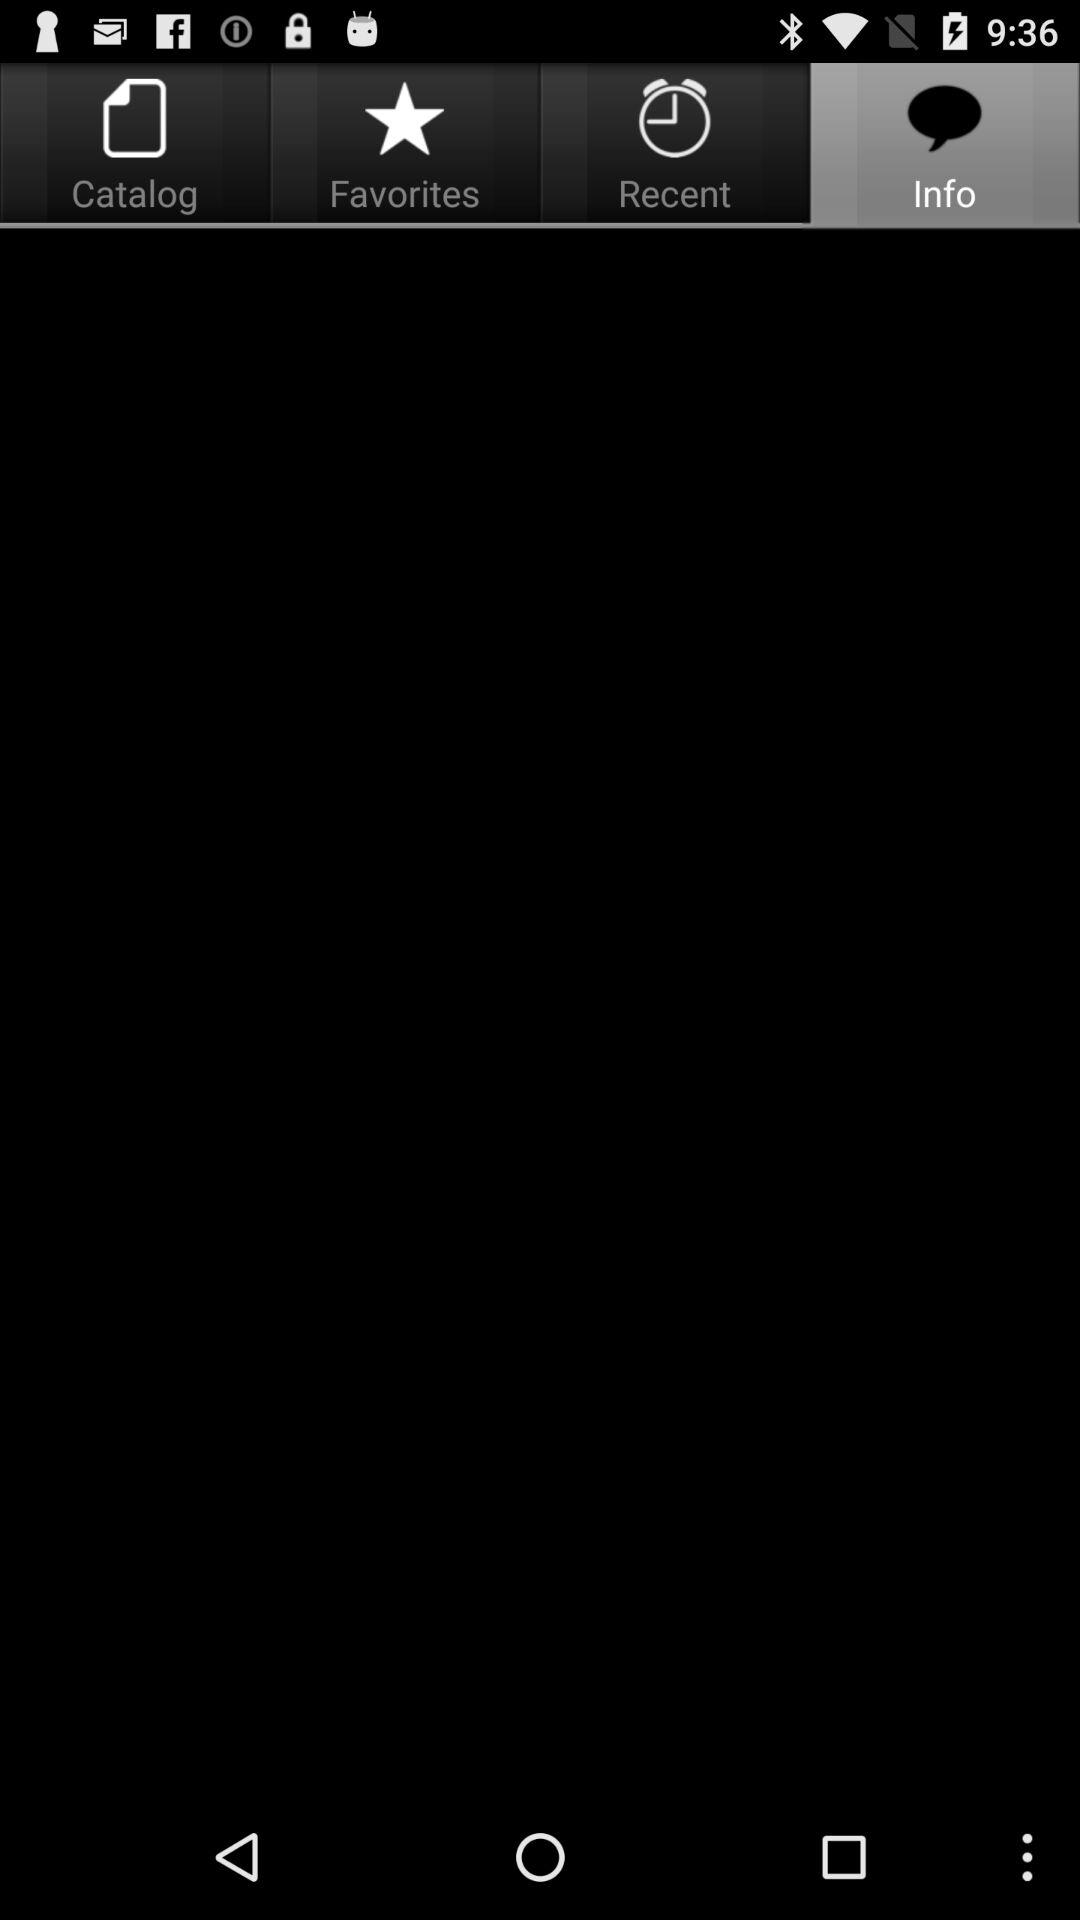Which tab is selected?
Answer the question using a single word or phrase. The tab selected is Info 